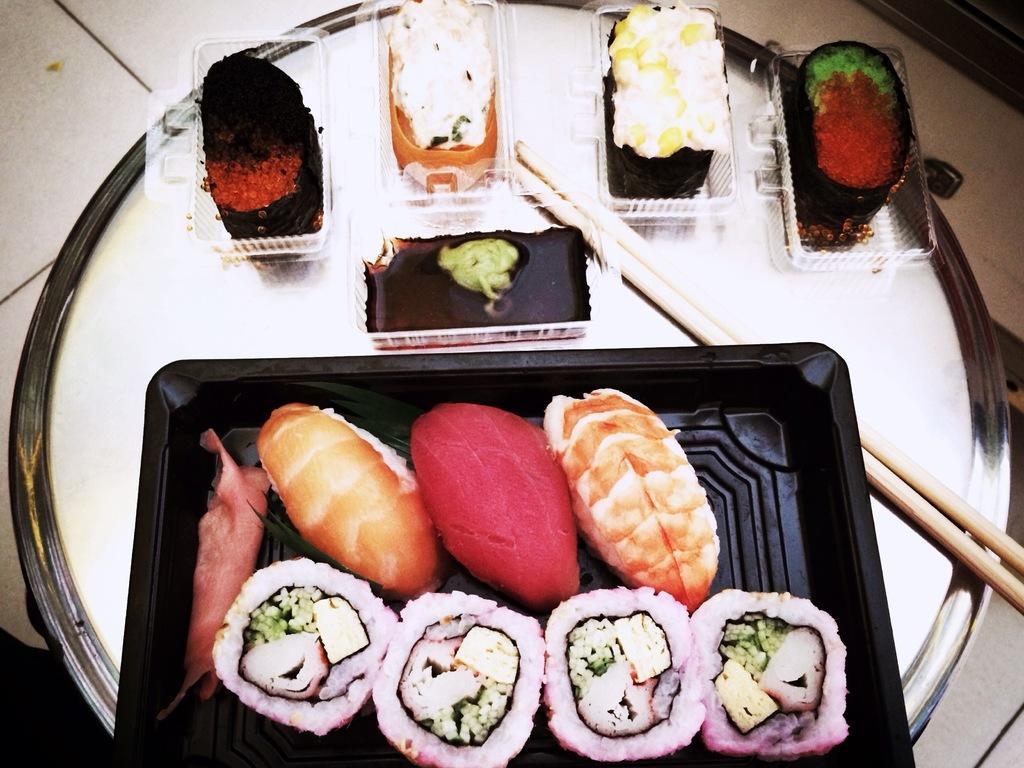Describe this image in one or two sentences. In the image we can see a plate. On the plate we can see food items in a plastic container. Here we can see chopsticks. 